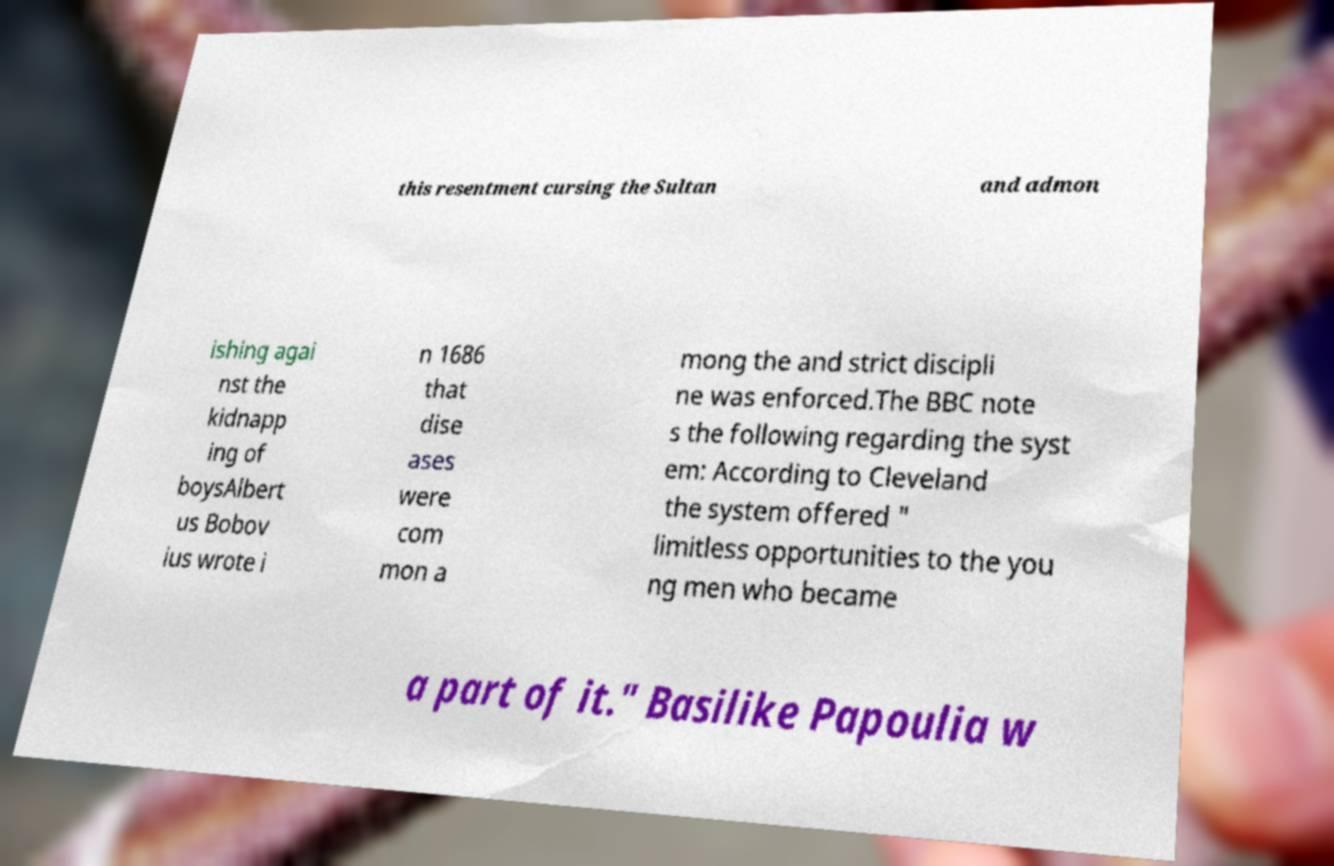What messages or text are displayed in this image? I need them in a readable, typed format. this resentment cursing the Sultan and admon ishing agai nst the kidnapp ing of boysAlbert us Bobov ius wrote i n 1686 that dise ases were com mon a mong the and strict discipli ne was enforced.The BBC note s the following regarding the syst em: According to Cleveland the system offered " limitless opportunities to the you ng men who became a part of it." Basilike Papoulia w 